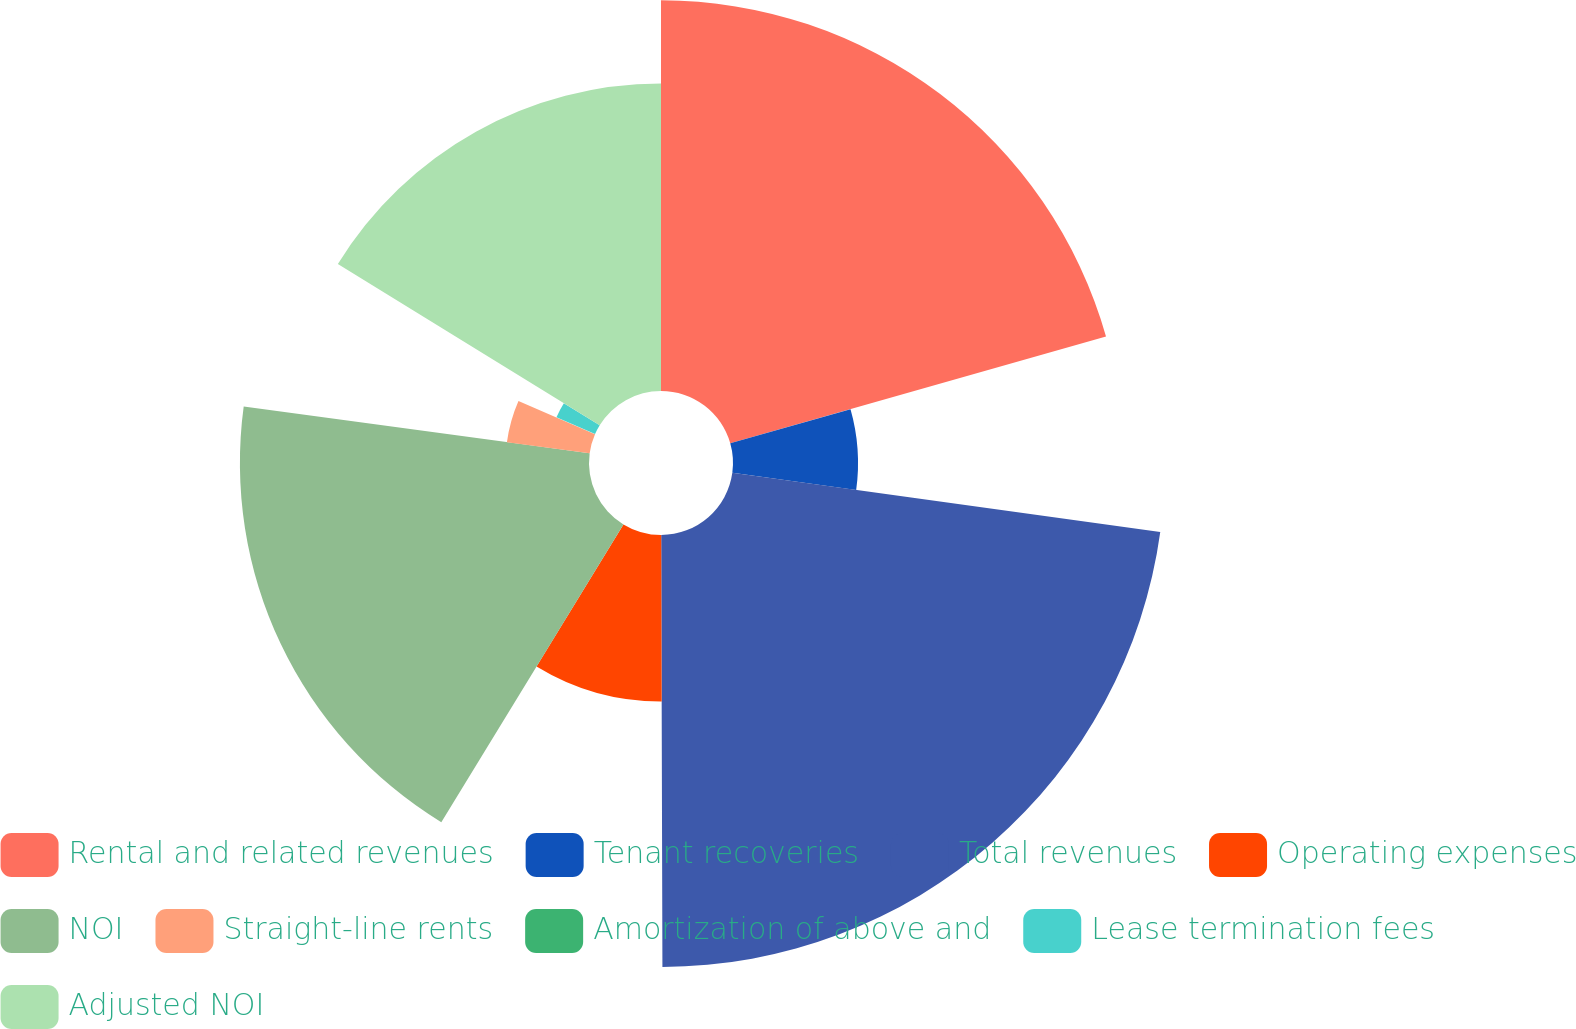Convert chart. <chart><loc_0><loc_0><loc_500><loc_500><pie_chart><fcel>Rental and related revenues<fcel>Tenant recoveries<fcel>Total revenues<fcel>Operating expenses<fcel>NOI<fcel>Straight-line rents<fcel>Amortization of above and<fcel>Lease termination fees<fcel>Adjusted NOI<nl><fcel>20.59%<fcel>6.59%<fcel>22.77%<fcel>8.78%<fcel>18.4%<fcel>4.4%<fcel>0.03%<fcel>2.22%<fcel>16.21%<nl></chart> 